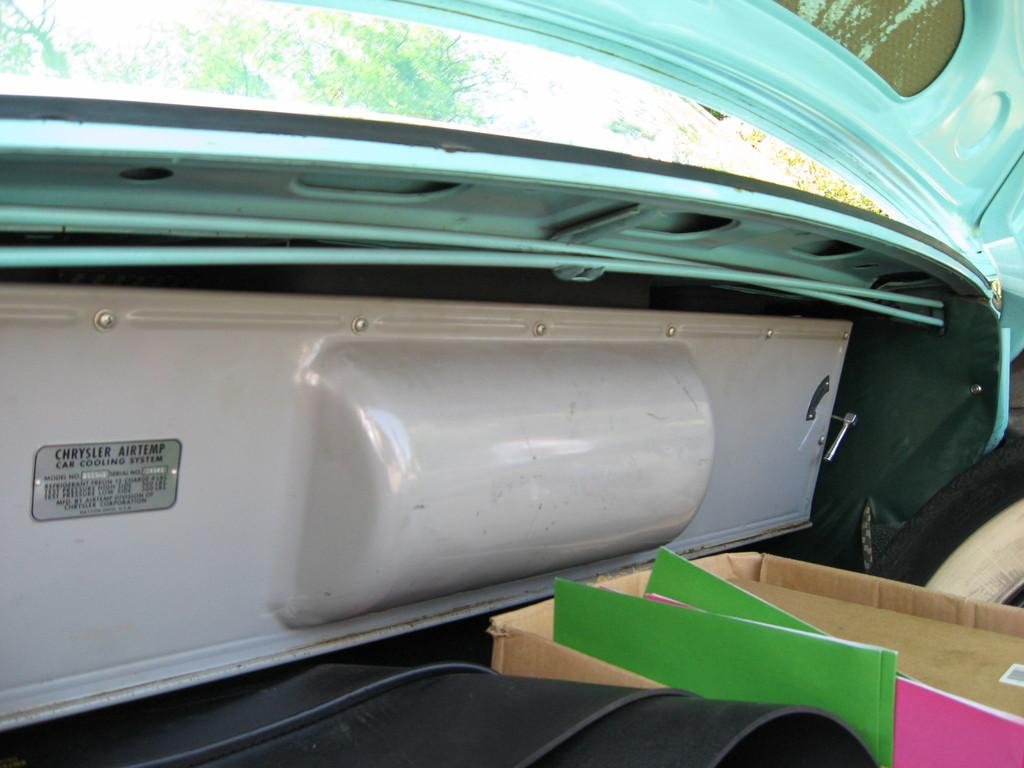What type of vehicle is in the image? The image contains a vehicle, but the specific type is not mentioned. What is inside the vehicle? There is a cardboard box and files and other objects inside the vehicle. What can be seen in the background of the image? Trees are visible at the top of the image. Where is the table located in the image? There is no table present in the image. What type of pan is being used to cook in the image? There is no pan or cooking activity depicted in the image. 